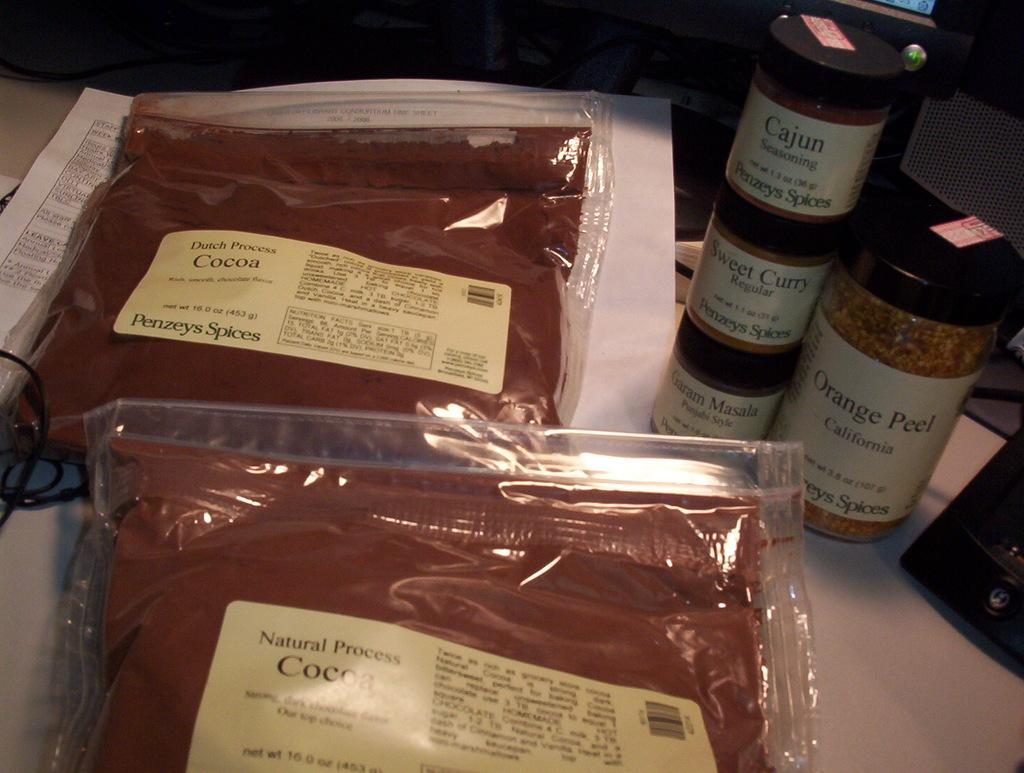<image>
Describe the image concisely. A bag of natural process cocoa sits with other spices on a table. 